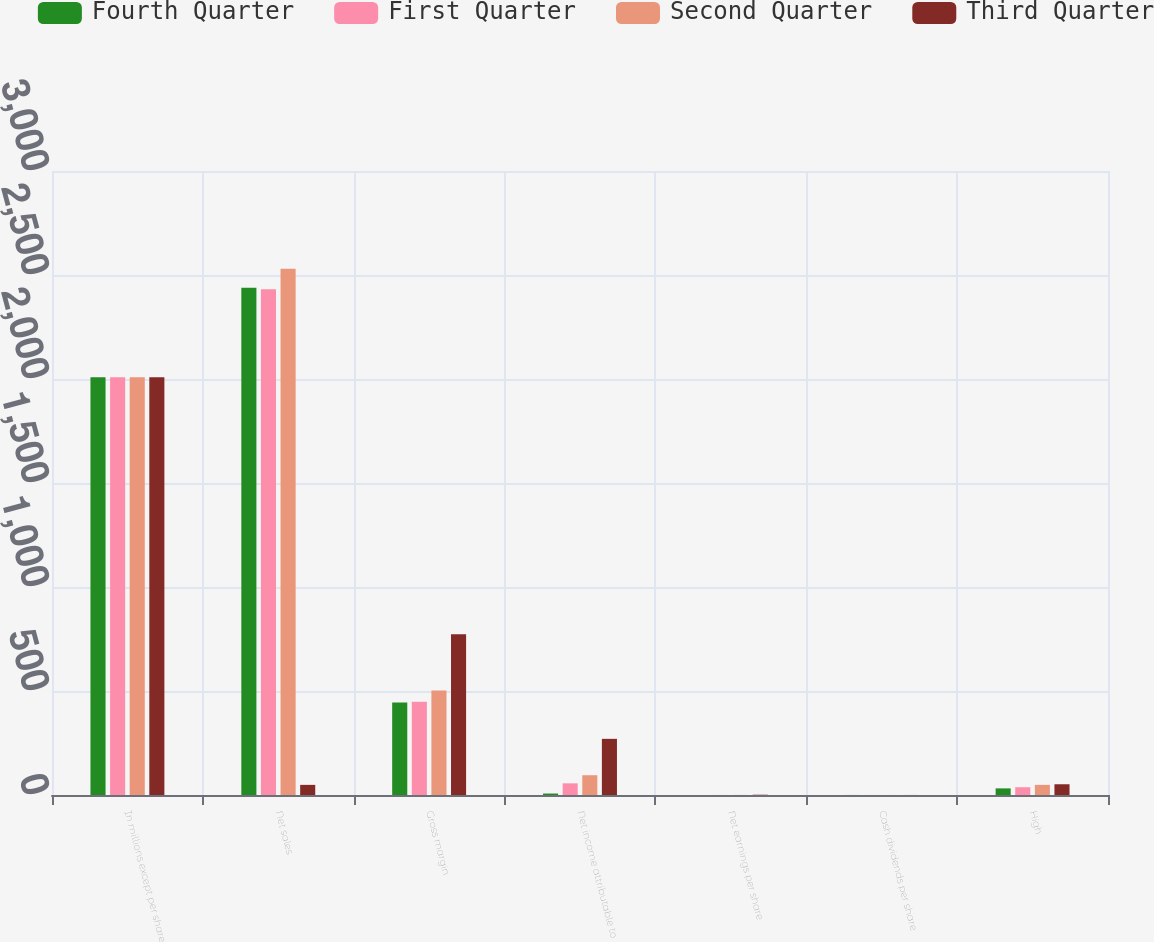<chart> <loc_0><loc_0><loc_500><loc_500><stacked_bar_chart><ecel><fcel>In millions except per share<fcel>Net sales<fcel>Gross margin<fcel>Net income attributable to<fcel>Net earnings per share<fcel>Cash dividends per share<fcel>High<nl><fcel>Fourth Quarter<fcel>2009<fcel>2439<fcel>445<fcel>7<fcel>0.04<fcel>0.17<fcel>31.77<nl><fcel>First Quarter<fcel>2009<fcel>2431<fcel>448<fcel>56<fcel>0.28<fcel>0.17<fcel>37.4<nl><fcel>Second Quarter<fcel>2009<fcel>2530<fcel>503<fcel>95<fcel>0.48<fcel>0.17<fcel>48.71<nl><fcel>Third Quarter<fcel>2009<fcel>48.71<fcel>773<fcel>270<fcel>1.36<fcel>0.17<fcel>51.65<nl></chart> 